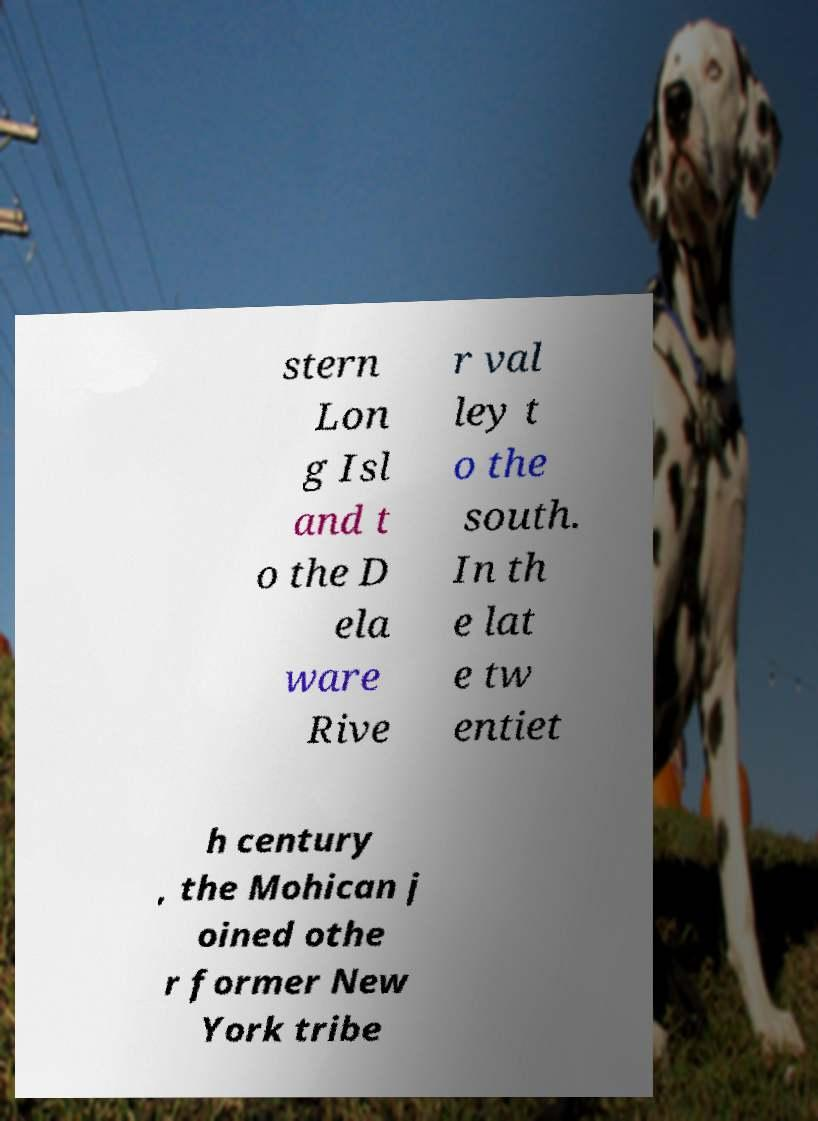What messages or text are displayed in this image? I need them in a readable, typed format. stern Lon g Isl and t o the D ela ware Rive r val ley t o the south. In th e lat e tw entiet h century , the Mohican j oined othe r former New York tribe 